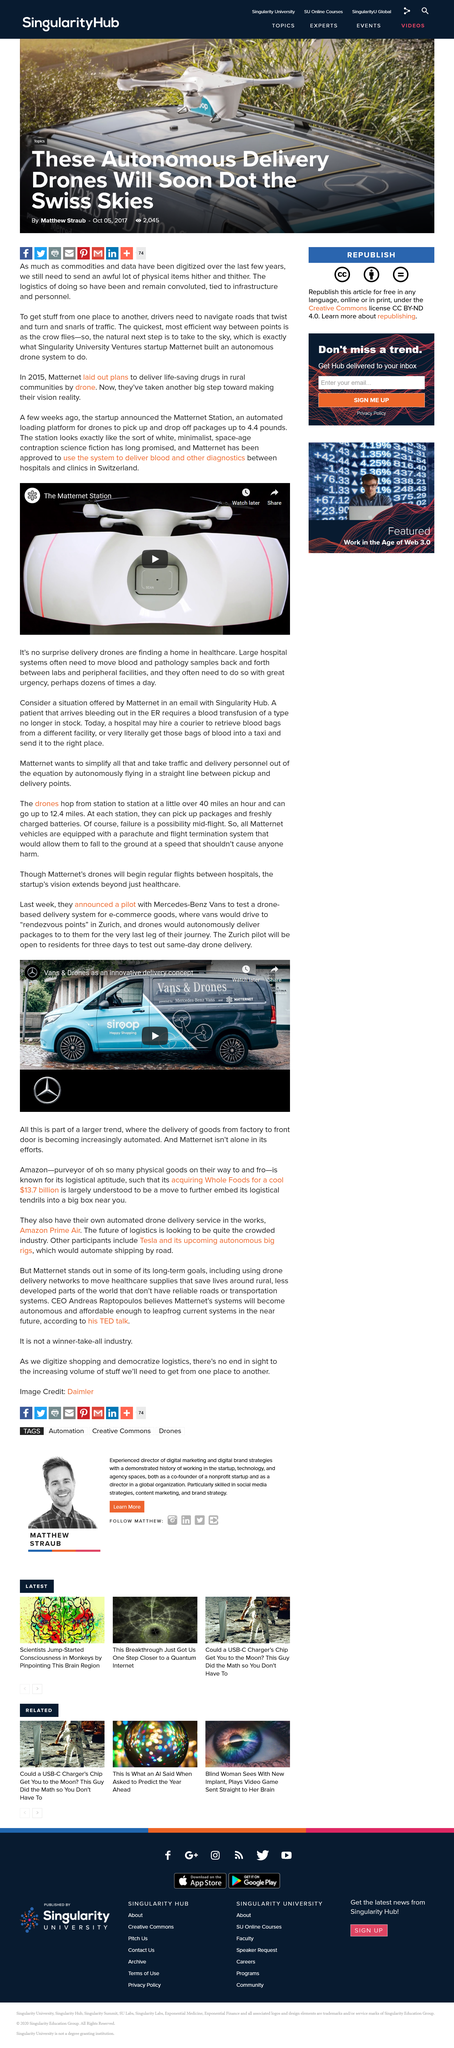Draw attention to some important aspects in this diagram. Mercedes-Benz has partnered with a car company to test the use of drones for delivery. According to the article, the system will be utilized in Switzerland to transport blood and other diagnostic tests between hospitals and clinics. The testing phase for automated delivery for residents of Zurich is expected to last for a total of three days. The automated loading platform discussed in the article is called the Matternet Station. Vans and Drones is powered by Mercedez-Benz, a car company. 